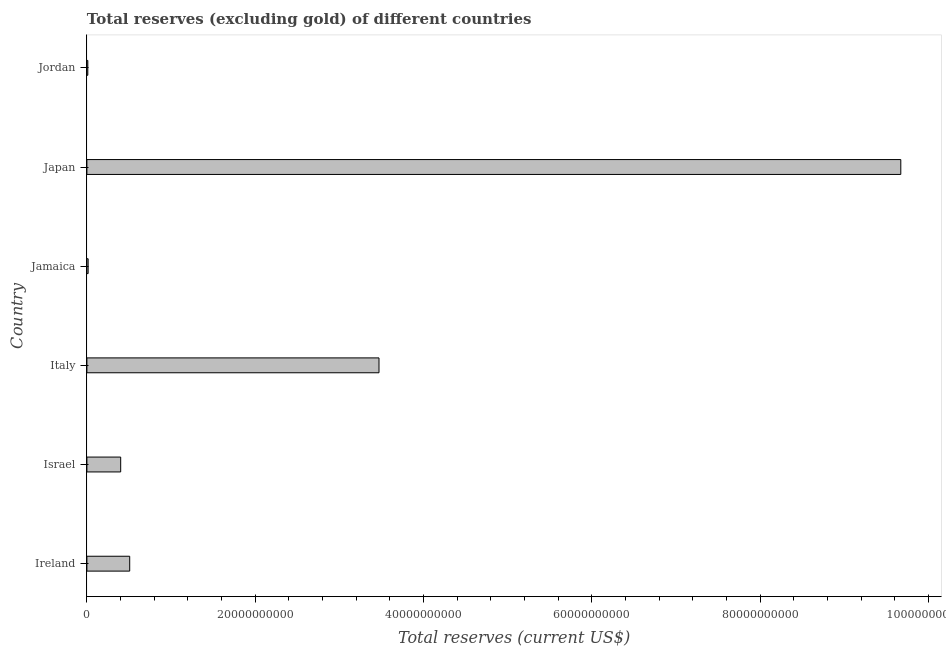Does the graph contain any zero values?
Your response must be concise. No. Does the graph contain grids?
Provide a succinct answer. No. What is the title of the graph?
Make the answer very short. Total reserves (excluding gold) of different countries. What is the label or title of the X-axis?
Provide a succinct answer. Total reserves (current US$). What is the total reserves (excluding gold) in Jamaica?
Make the answer very short. 1.47e+08. Across all countries, what is the maximum total reserves (excluding gold)?
Keep it short and to the point. 9.67e+1. Across all countries, what is the minimum total reserves (excluding gold)?
Give a very brief answer. 1.10e+08. In which country was the total reserves (excluding gold) maximum?
Provide a short and direct response. Japan. In which country was the total reserves (excluding gold) minimum?
Keep it short and to the point. Jordan. What is the sum of the total reserves (excluding gold)?
Your response must be concise. 1.41e+11. What is the difference between the total reserves (excluding gold) in Japan and Jordan?
Keep it short and to the point. 9.66e+1. What is the average total reserves (excluding gold) per country?
Keep it short and to the point. 2.35e+1. What is the median total reserves (excluding gold)?
Give a very brief answer. 4.55e+09. In how many countries, is the total reserves (excluding gold) greater than 68000000000 US$?
Make the answer very short. 1. What is the ratio of the total reserves (excluding gold) in Italy to that in Japan?
Your response must be concise. 0.36. Is the total reserves (excluding gold) in Ireland less than that in Israel?
Your answer should be very brief. No. Is the difference between the total reserves (excluding gold) in Japan and Jordan greater than the difference between any two countries?
Ensure brevity in your answer.  Yes. What is the difference between the highest and the second highest total reserves (excluding gold)?
Your answer should be compact. 6.20e+1. What is the difference between the highest and the lowest total reserves (excluding gold)?
Make the answer very short. 9.66e+1. In how many countries, is the total reserves (excluding gold) greater than the average total reserves (excluding gold) taken over all countries?
Your response must be concise. 2. What is the Total reserves (current US$) in Ireland?
Ensure brevity in your answer.  5.09e+09. What is the Total reserves (current US$) in Israel?
Give a very brief answer. 4.02e+09. What is the Total reserves (current US$) of Italy?
Your answer should be very brief. 3.47e+1. What is the Total reserves (current US$) in Jamaica?
Your answer should be very brief. 1.47e+08. What is the Total reserves (current US$) of Japan?
Ensure brevity in your answer.  9.67e+1. What is the Total reserves (current US$) in Jordan?
Keep it short and to the point. 1.10e+08. What is the difference between the Total reserves (current US$) in Ireland and Israel?
Keep it short and to the point. 1.07e+09. What is the difference between the Total reserves (current US$) in Ireland and Italy?
Make the answer very short. -2.96e+1. What is the difference between the Total reserves (current US$) in Ireland and Jamaica?
Provide a short and direct response. 4.94e+09. What is the difference between the Total reserves (current US$) in Ireland and Japan?
Your answer should be very brief. -9.16e+1. What is the difference between the Total reserves (current US$) in Ireland and Jordan?
Provide a short and direct response. 4.98e+09. What is the difference between the Total reserves (current US$) in Israel and Italy?
Your response must be concise. -3.07e+1. What is the difference between the Total reserves (current US$) in Israel and Jamaica?
Provide a short and direct response. 3.87e+09. What is the difference between the Total reserves (current US$) in Israel and Japan?
Your answer should be compact. -9.27e+1. What is the difference between the Total reserves (current US$) in Israel and Jordan?
Offer a terse response. 3.91e+09. What is the difference between the Total reserves (current US$) in Italy and Jamaica?
Offer a very short reply. 3.46e+1. What is the difference between the Total reserves (current US$) in Italy and Japan?
Your answer should be very brief. -6.20e+1. What is the difference between the Total reserves (current US$) in Italy and Jordan?
Provide a short and direct response. 3.46e+1. What is the difference between the Total reserves (current US$) in Jamaica and Japan?
Make the answer very short. -9.66e+1. What is the difference between the Total reserves (current US$) in Jamaica and Jordan?
Offer a very short reply. 3.76e+07. What is the difference between the Total reserves (current US$) in Japan and Jordan?
Provide a short and direct response. 9.66e+1. What is the ratio of the Total reserves (current US$) in Ireland to that in Israel?
Give a very brief answer. 1.27. What is the ratio of the Total reserves (current US$) in Ireland to that in Italy?
Offer a terse response. 0.15. What is the ratio of the Total reserves (current US$) in Ireland to that in Jamaica?
Make the answer very short. 34.56. What is the ratio of the Total reserves (current US$) in Ireland to that in Japan?
Ensure brevity in your answer.  0.05. What is the ratio of the Total reserves (current US$) in Ireland to that in Jordan?
Make the answer very short. 46.43. What is the ratio of the Total reserves (current US$) in Israel to that in Italy?
Your answer should be very brief. 0.12. What is the ratio of the Total reserves (current US$) in Israel to that in Jamaica?
Offer a terse response. 27.28. What is the ratio of the Total reserves (current US$) in Israel to that in Japan?
Give a very brief answer. 0.04. What is the ratio of the Total reserves (current US$) in Israel to that in Jordan?
Provide a short and direct response. 36.65. What is the ratio of the Total reserves (current US$) in Italy to that in Jamaica?
Offer a terse response. 235.84. What is the ratio of the Total reserves (current US$) in Italy to that in Japan?
Offer a terse response. 0.36. What is the ratio of the Total reserves (current US$) in Italy to that in Jordan?
Your answer should be compact. 316.88. What is the ratio of the Total reserves (current US$) in Jamaica to that in Japan?
Give a very brief answer. 0. What is the ratio of the Total reserves (current US$) in Jamaica to that in Jordan?
Offer a very short reply. 1.34. What is the ratio of the Total reserves (current US$) in Japan to that in Jordan?
Keep it short and to the point. 882.93. 